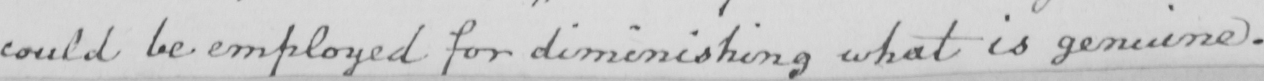Can you read and transcribe this handwriting? could be employed for diminishing what is genuine . 